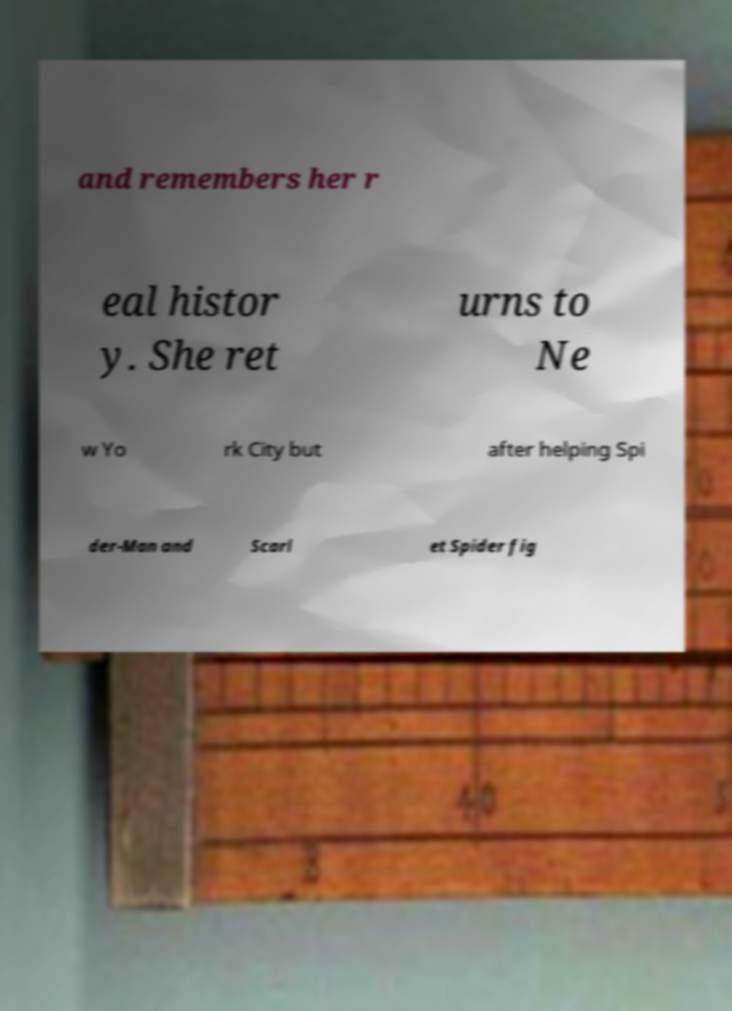Could you extract and type out the text from this image? and remembers her r eal histor y. She ret urns to Ne w Yo rk City but after helping Spi der-Man and Scarl et Spider fig 